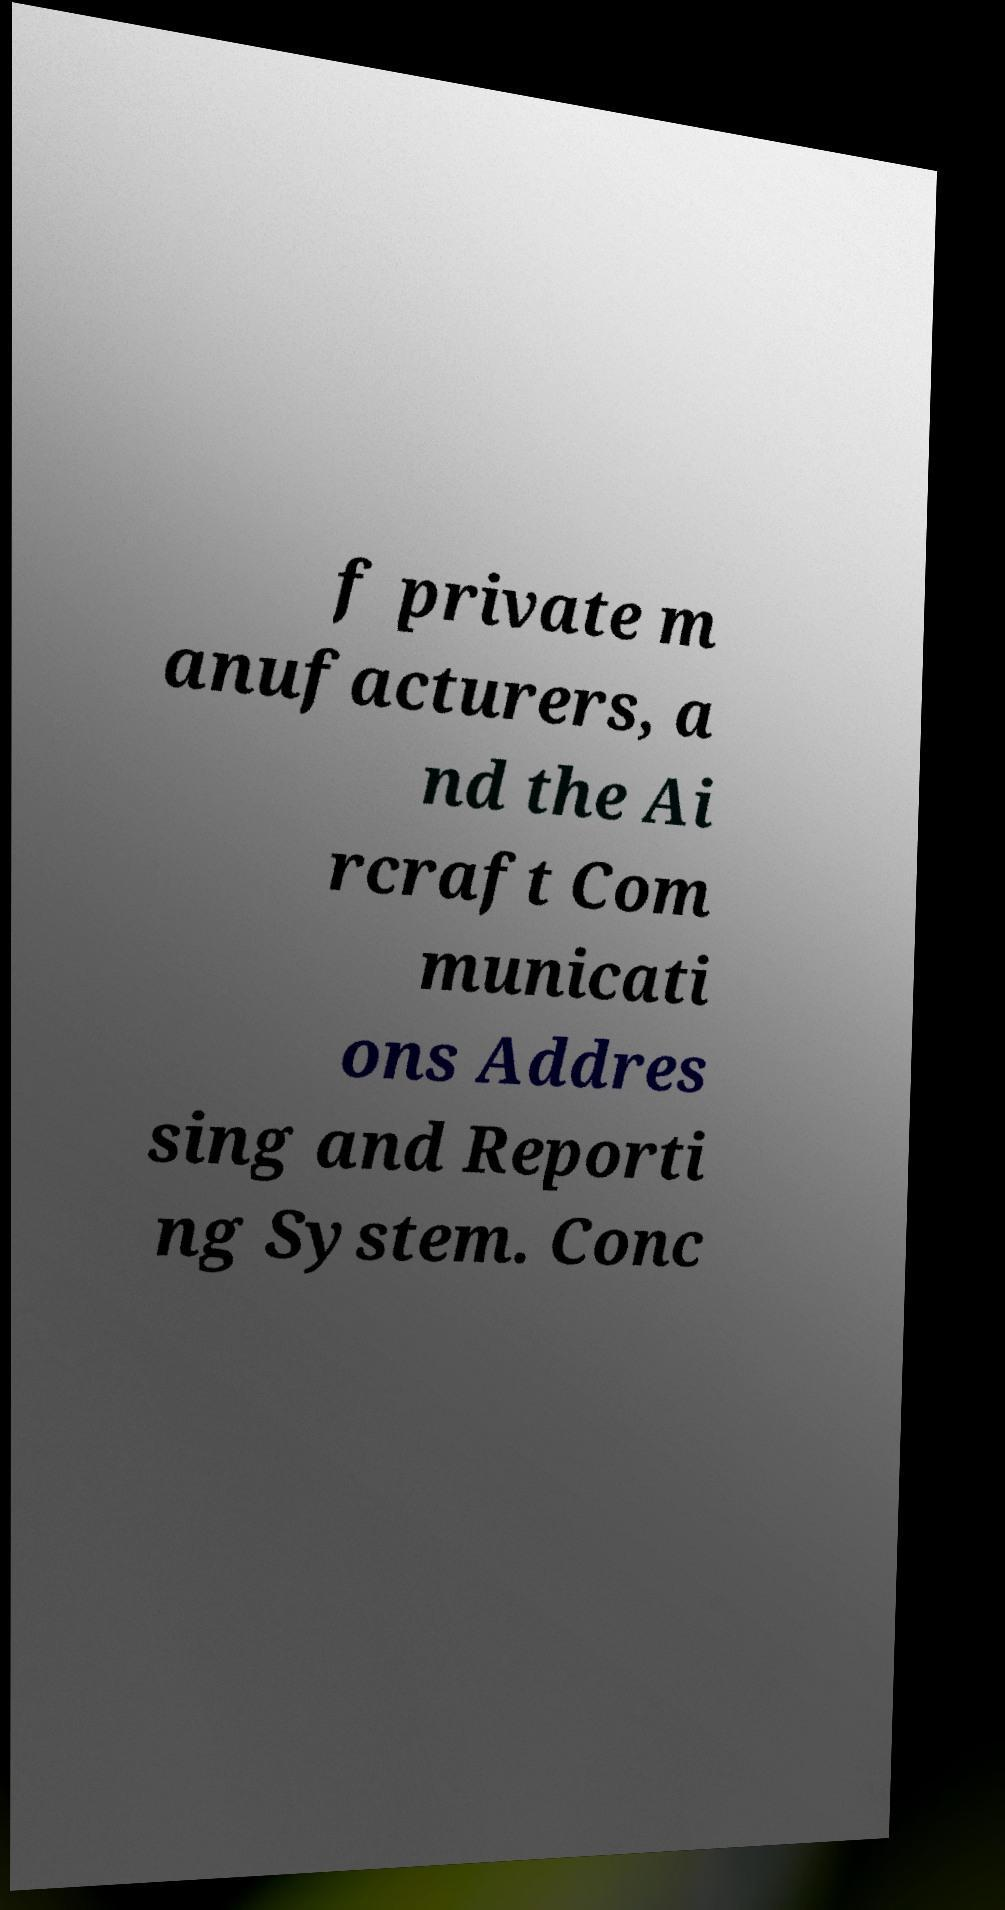There's text embedded in this image that I need extracted. Can you transcribe it verbatim? f private m anufacturers, a nd the Ai rcraft Com municati ons Addres sing and Reporti ng System. Conc 